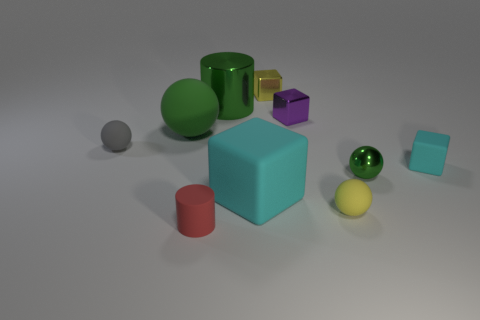Can you describe the texture of the large blue cube in the center? The large blue cube in the center has a matte finish, with a slightly rough texture that is less reflective than some of the other objects. What does the surface texture suggest about the material of the cube? The matte and slightly rough texture of the cube suggests it could be made of a material like painted wood or a matte plastic, which typically have less glossy finishes. 